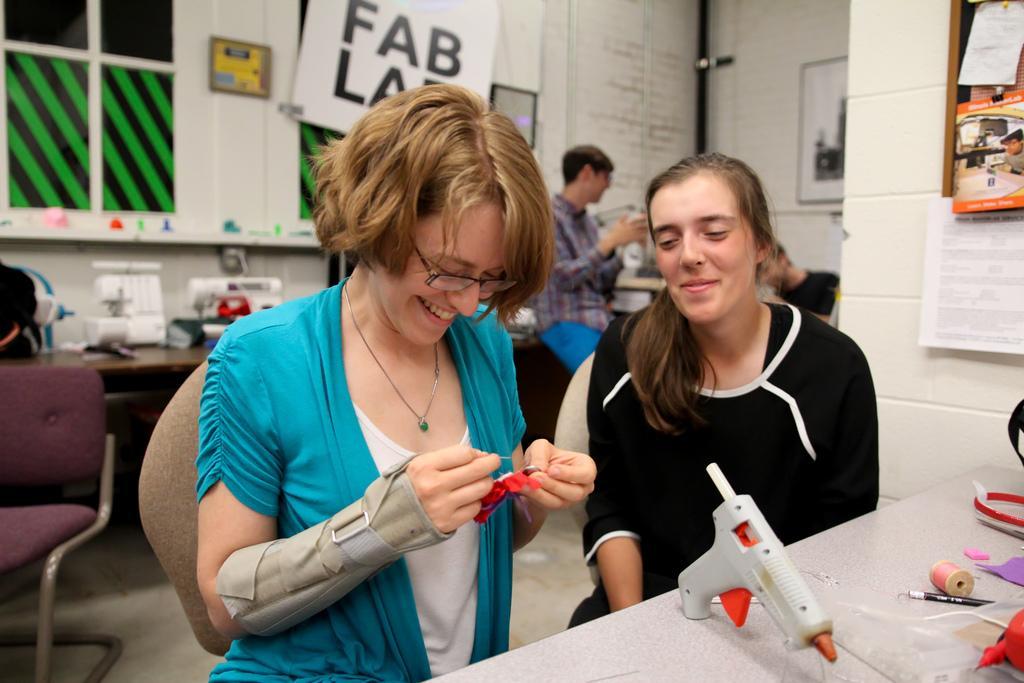Please provide a concise description of this image. These two women are sitting on a chair. In-front of this woman there is a table, on a table there is a thread, pencil and glue gun. This woman wore spectacles, holds smile and holds a badge. This woman holds smile and wore black t-shirt. Far this person is standing. On wall there are pictures and posters. On this table there are things. This is chair. 